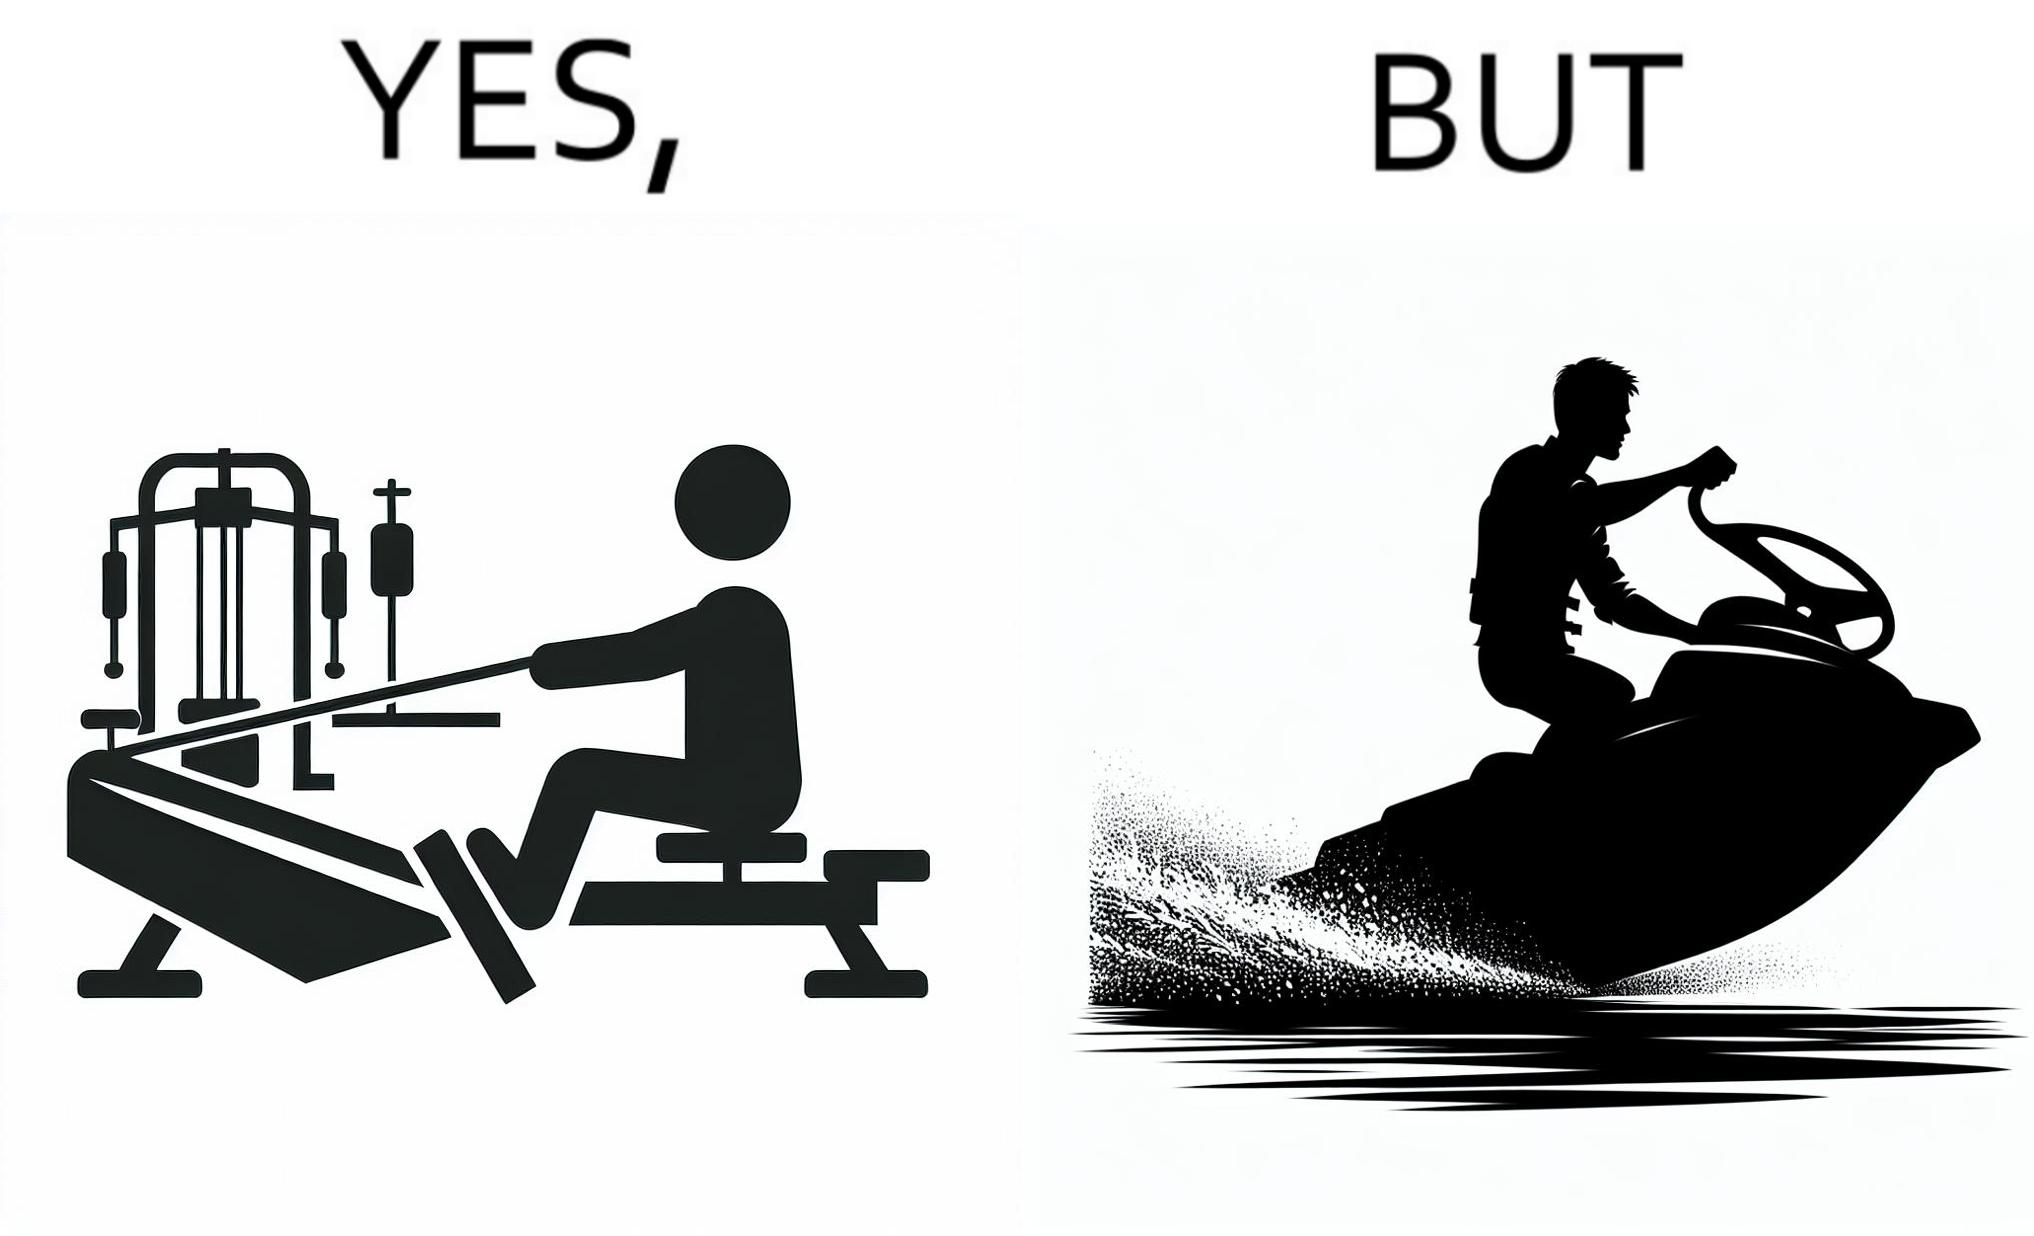Describe the contrast between the left and right parts of this image. In the left part of the image: a person doing rowing exercise in gym In the right part of the image: a person riding a motorboat 